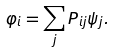<formula> <loc_0><loc_0><loc_500><loc_500>\varphi _ { i } = \sum _ { j } P _ { i j } \psi _ { j } .</formula> 